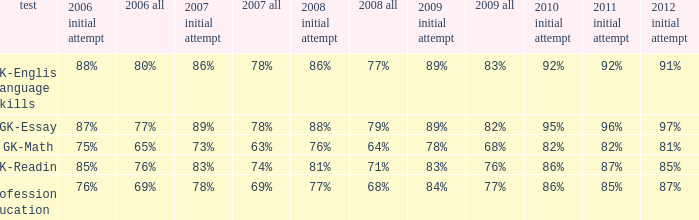What is the percentage for all in 2007 when all in 2006 was 65%? 63%. 